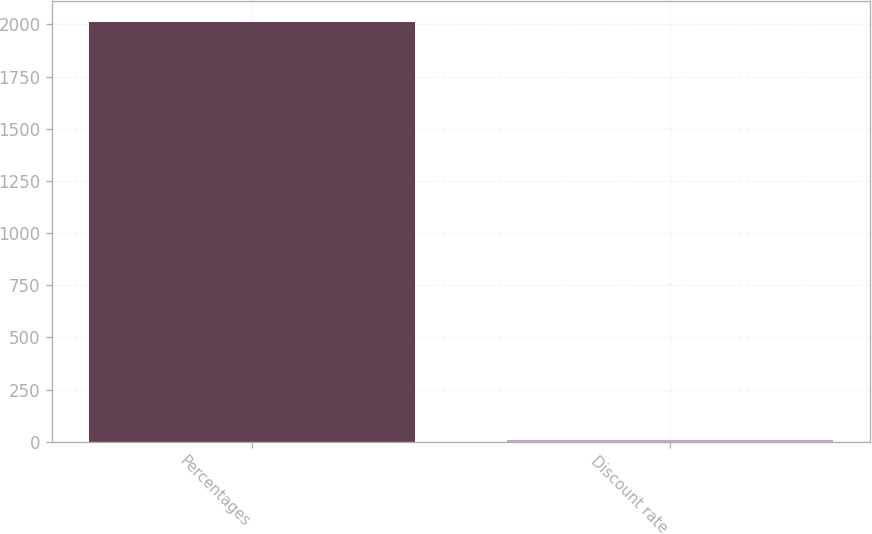Convert chart. <chart><loc_0><loc_0><loc_500><loc_500><bar_chart><fcel>Percentages<fcel>Discount rate<nl><fcel>2010<fcel>5.9<nl></chart> 